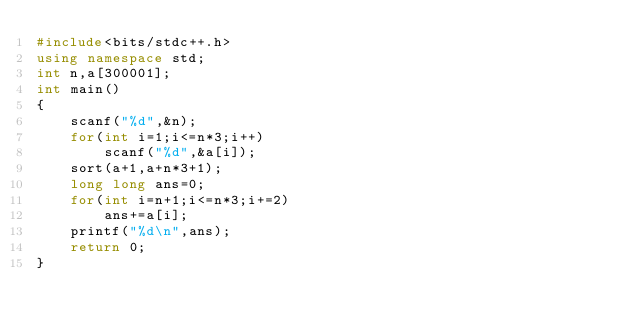Convert code to text. <code><loc_0><loc_0><loc_500><loc_500><_C++_>#include<bits/stdc++.h>
using namespace std;
int n,a[300001];
int main()
{
	scanf("%d",&n);
	for(int i=1;i<=n*3;i++)
		scanf("%d",&a[i]);
	sort(a+1,a+n*3+1);
	long long ans=0;
	for(int i=n+1;i<=n*3;i+=2)
		ans+=a[i];
	printf("%d\n",ans);
	return 0;
} </code> 